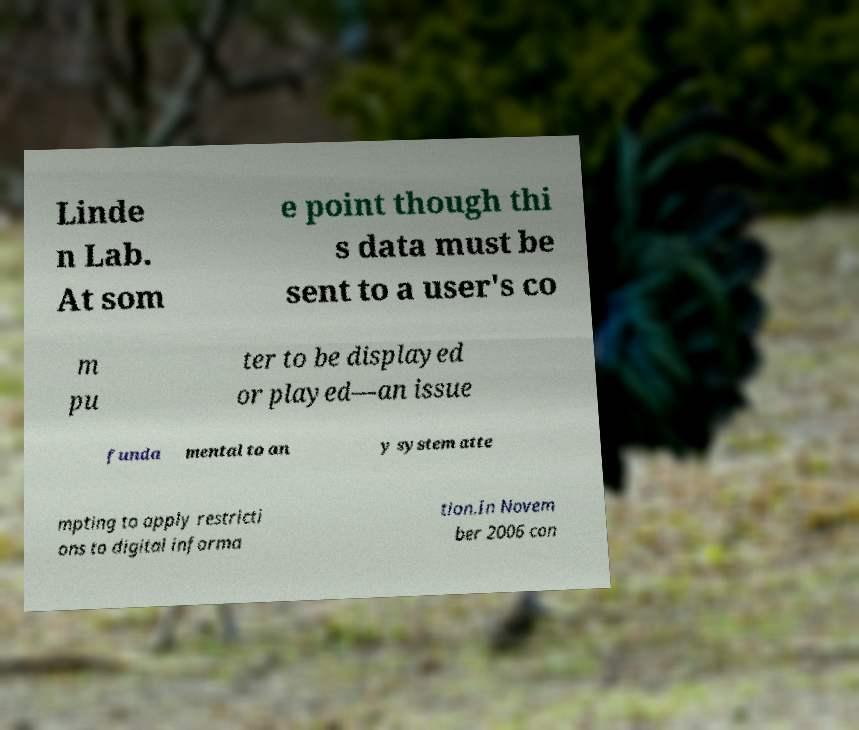I need the written content from this picture converted into text. Can you do that? Linde n Lab. At som e point though thi s data must be sent to a user's co m pu ter to be displayed or played—an issue funda mental to an y system atte mpting to apply restricti ons to digital informa tion.In Novem ber 2006 con 